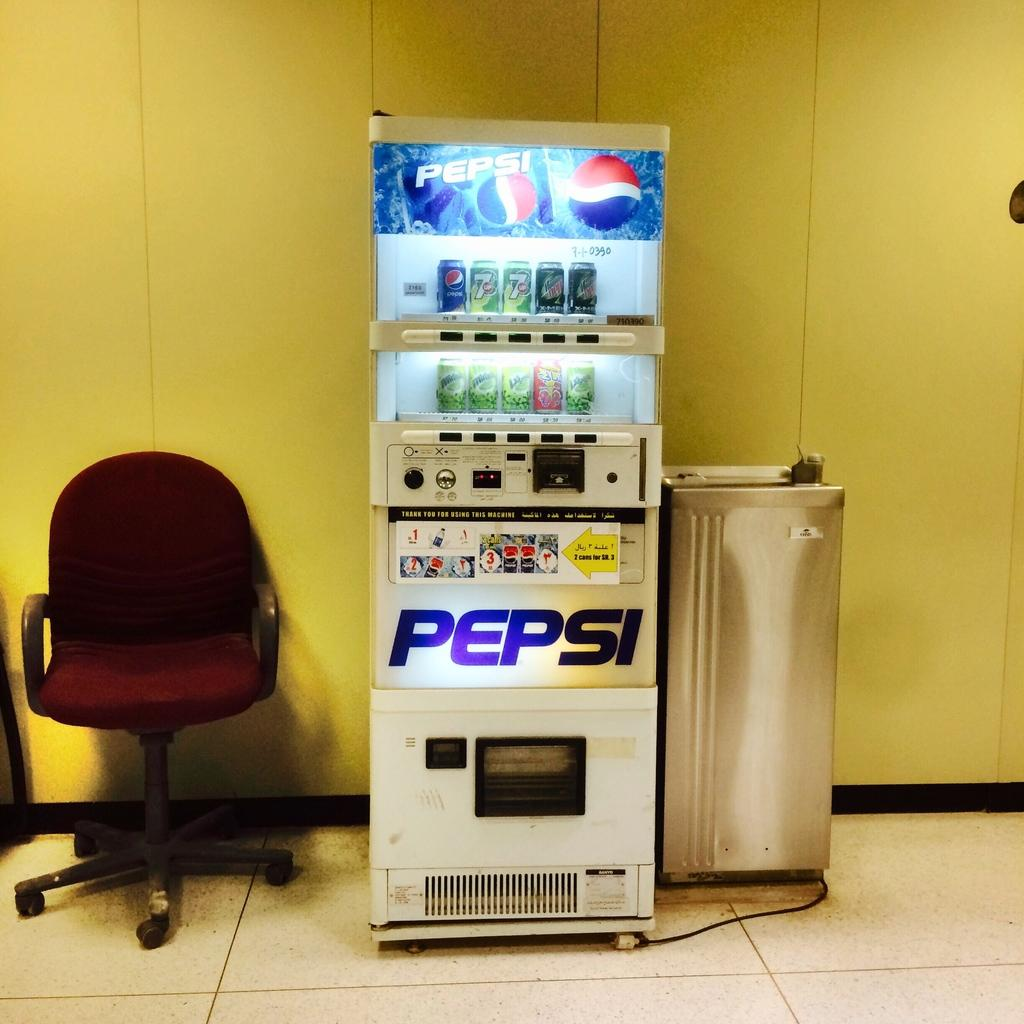<image>
Present a compact description of the photo's key features. A white Pepsi vending machines features Pepsi and many other drinks. 